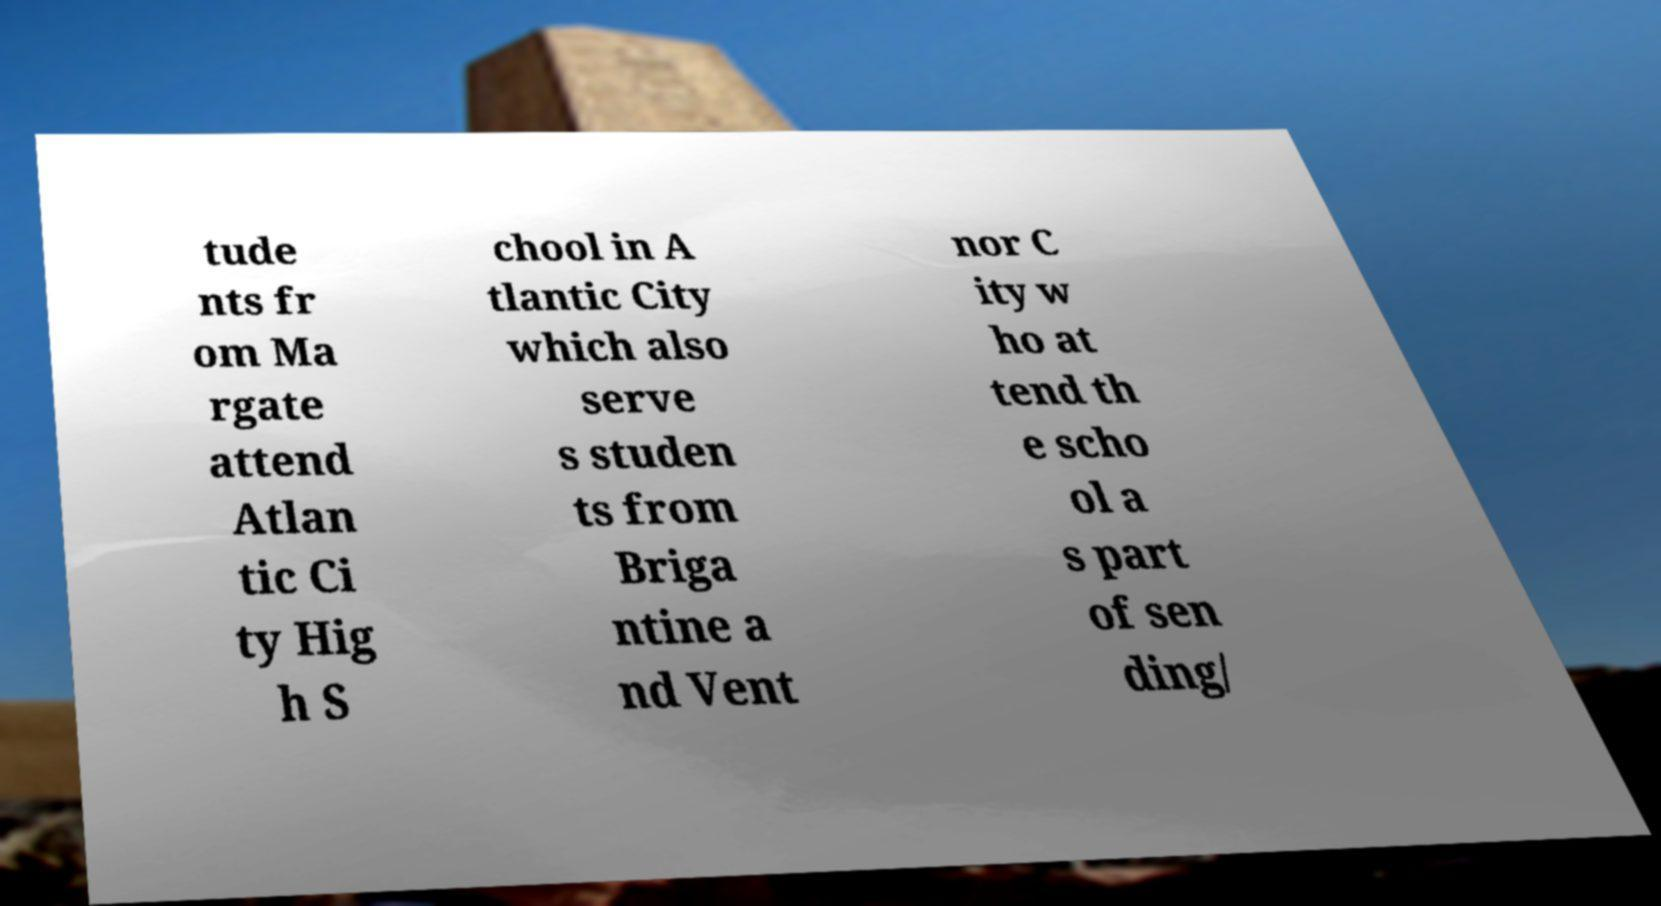Could you assist in decoding the text presented in this image and type it out clearly? tude nts fr om Ma rgate attend Atlan tic Ci ty Hig h S chool in A tlantic City which also serve s studen ts from Briga ntine a nd Vent nor C ity w ho at tend th e scho ol a s part of sen ding/ 